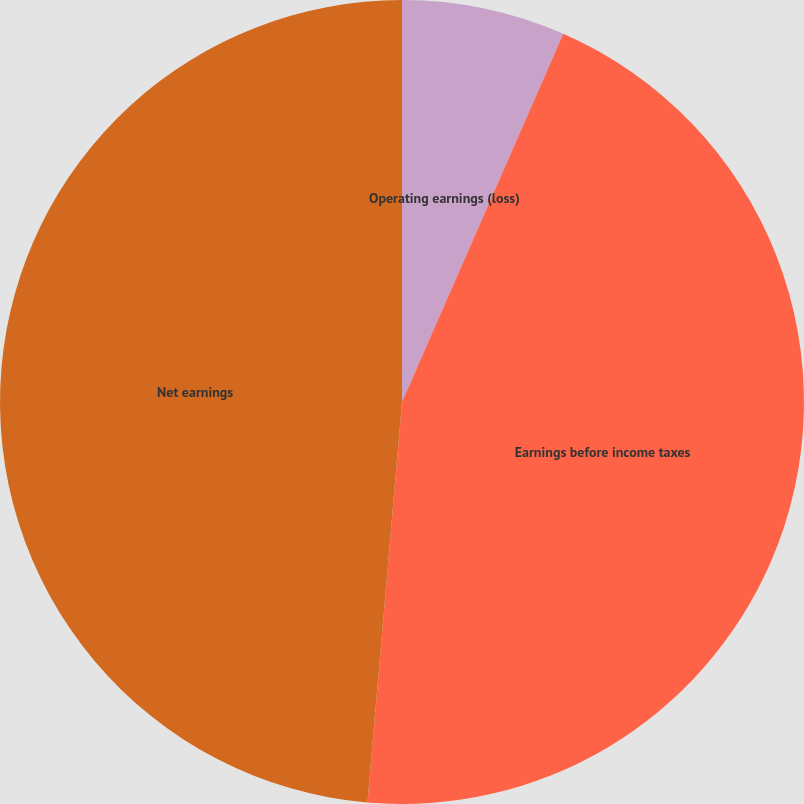Convert chart. <chart><loc_0><loc_0><loc_500><loc_500><pie_chart><fcel>Operating earnings (loss)<fcel>Earnings before income taxes<fcel>Net earnings<nl><fcel>6.57%<fcel>44.8%<fcel>48.63%<nl></chart> 